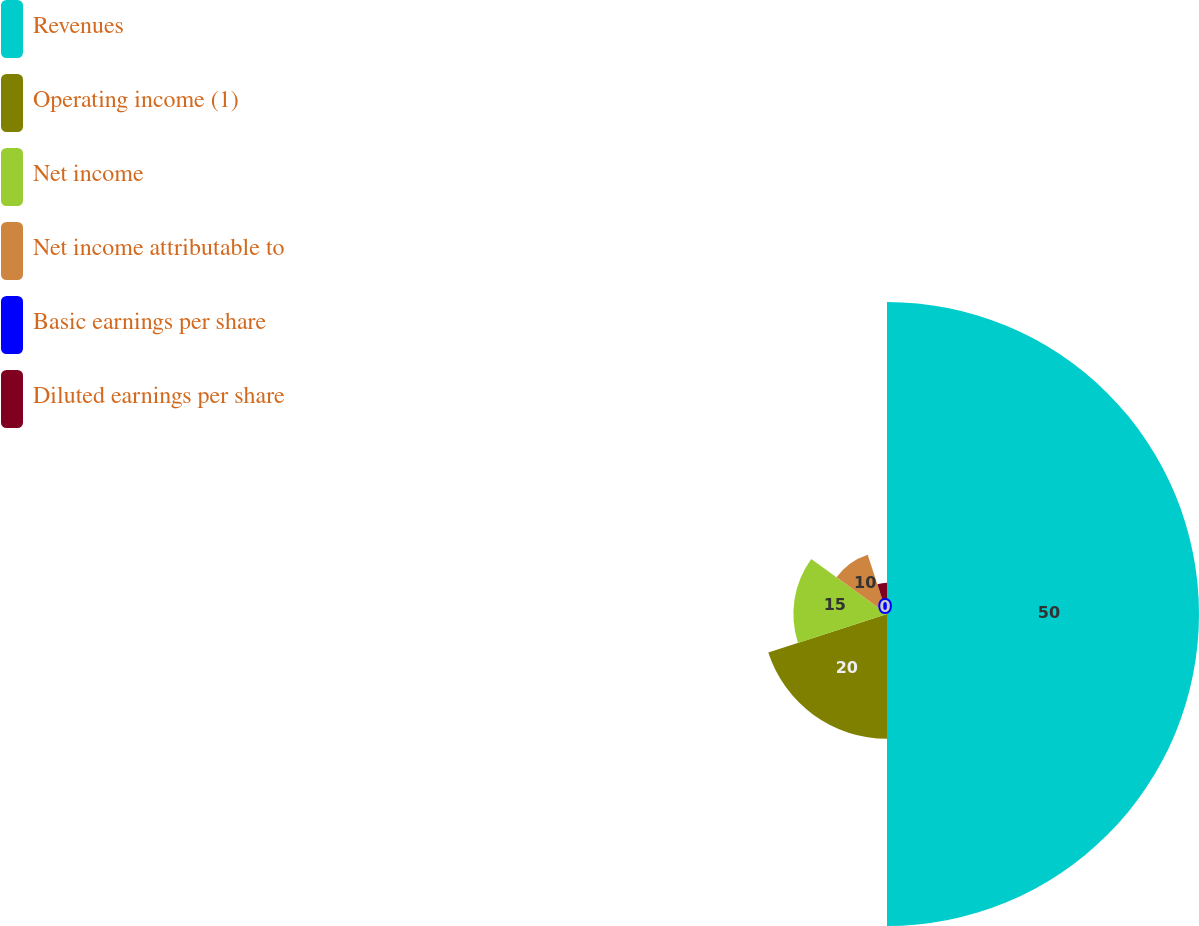Convert chart. <chart><loc_0><loc_0><loc_500><loc_500><pie_chart><fcel>Revenues<fcel>Operating income (1)<fcel>Net income<fcel>Net income attributable to<fcel>Basic earnings per share<fcel>Diluted earnings per share<nl><fcel>50.0%<fcel>20.0%<fcel>15.0%<fcel>10.0%<fcel>0.0%<fcel>5.0%<nl></chart> 